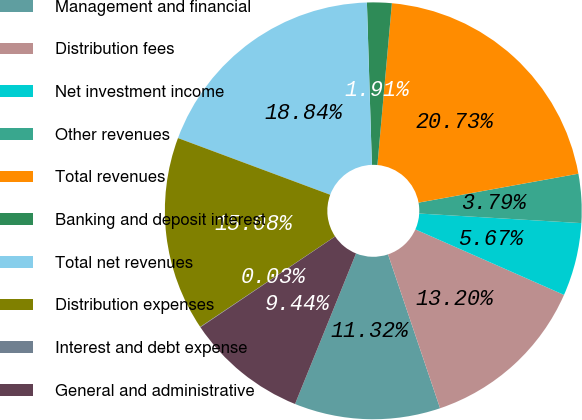Convert chart. <chart><loc_0><loc_0><loc_500><loc_500><pie_chart><fcel>Management and financial<fcel>Distribution fees<fcel>Net investment income<fcel>Other revenues<fcel>Total revenues<fcel>Banking and deposit interest<fcel>Total net revenues<fcel>Distribution expenses<fcel>Interest and debt expense<fcel>General and administrative<nl><fcel>11.32%<fcel>13.2%<fcel>5.67%<fcel>3.79%<fcel>20.73%<fcel>1.91%<fcel>18.84%<fcel>15.08%<fcel>0.03%<fcel>9.44%<nl></chart> 